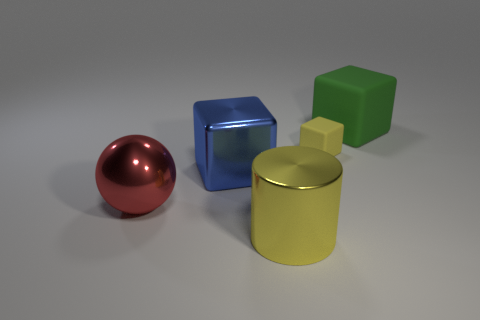What is the shape of the thing that is in front of the large blue block and behind the large shiny cylinder? sphere 